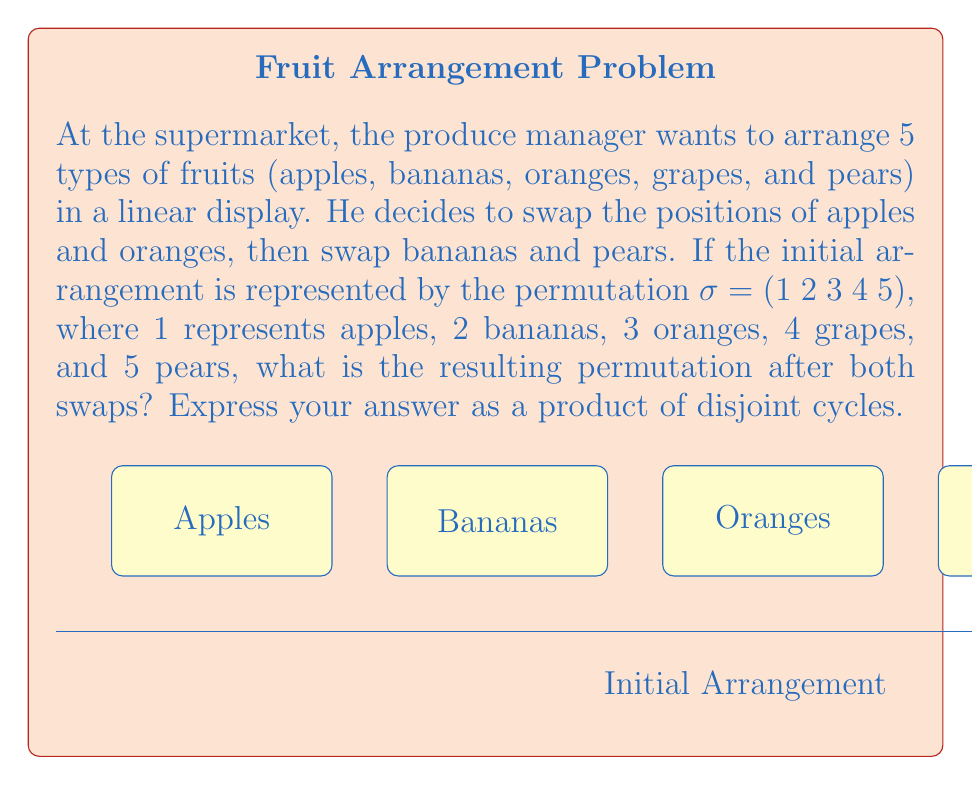Give your solution to this math problem. Let's approach this step-by-step:

1) The initial permutation is $\sigma = (1\;2\;3\;4\;5)$, which represents the identity permutation (fruits in their original order).

2) First, we swap apples (1) and oranges (3). This can be represented by the permutation $\alpha = (1\;3)$. 

3) Then, we swap bananas (2) and pears (5). This can be represented by the permutation $\beta = (2\;5)$.

4) To find the final arrangement, we need to compose these permutations. In group theory, we apply permutations from right to left. So, we need to calculate $\beta \circ \alpha \circ \sigma$.

5) Let's apply these permutations one by one:
   
   $\alpha \circ \sigma = (1\;3)(1\;2\;3\;4\;5) = (1\;2\;3\;4\;5)$
   
   This swaps 1 and 3 in the original permutation.

6) Now, let's apply $\beta$ to this result:
   
   $\beta \circ (\alpha \circ \sigma) = (2\;5)(1\;3\;2\;4\;5) = (1\;3\;5\;4\;2)$

7) To verify:
   - 1 (apples) goes to 3
   - 3 (oranges) goes to 5
   - 5 (pears) goes to 4
   - 4 (grapes) stays at 4
   - 2 (bananas) goes to 1

Therefore, the final permutation after both swaps is $(1\;3\;5\;4\;2)$.
Answer: $(1\;3\;5\;4\;2)$ 